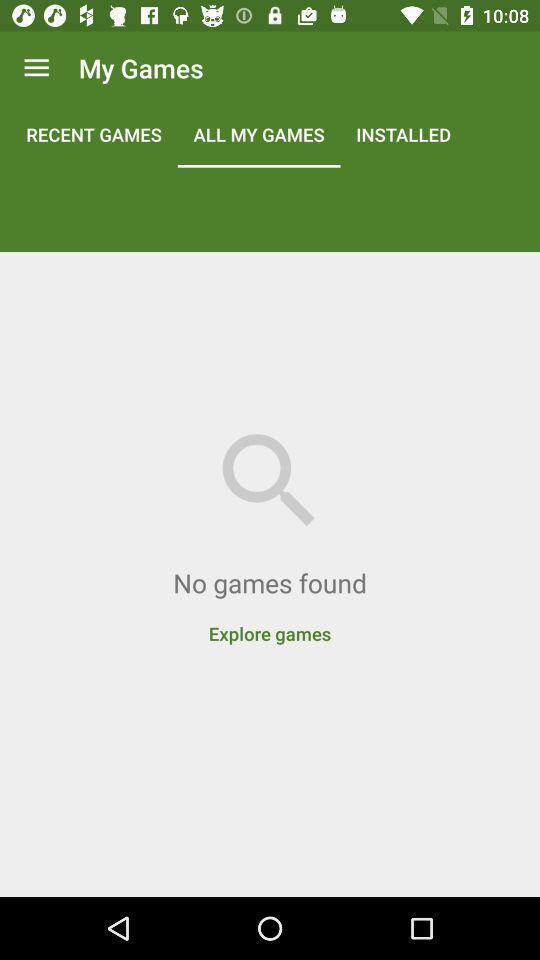Summarize the main components in this picture. Window displaying an games app. 